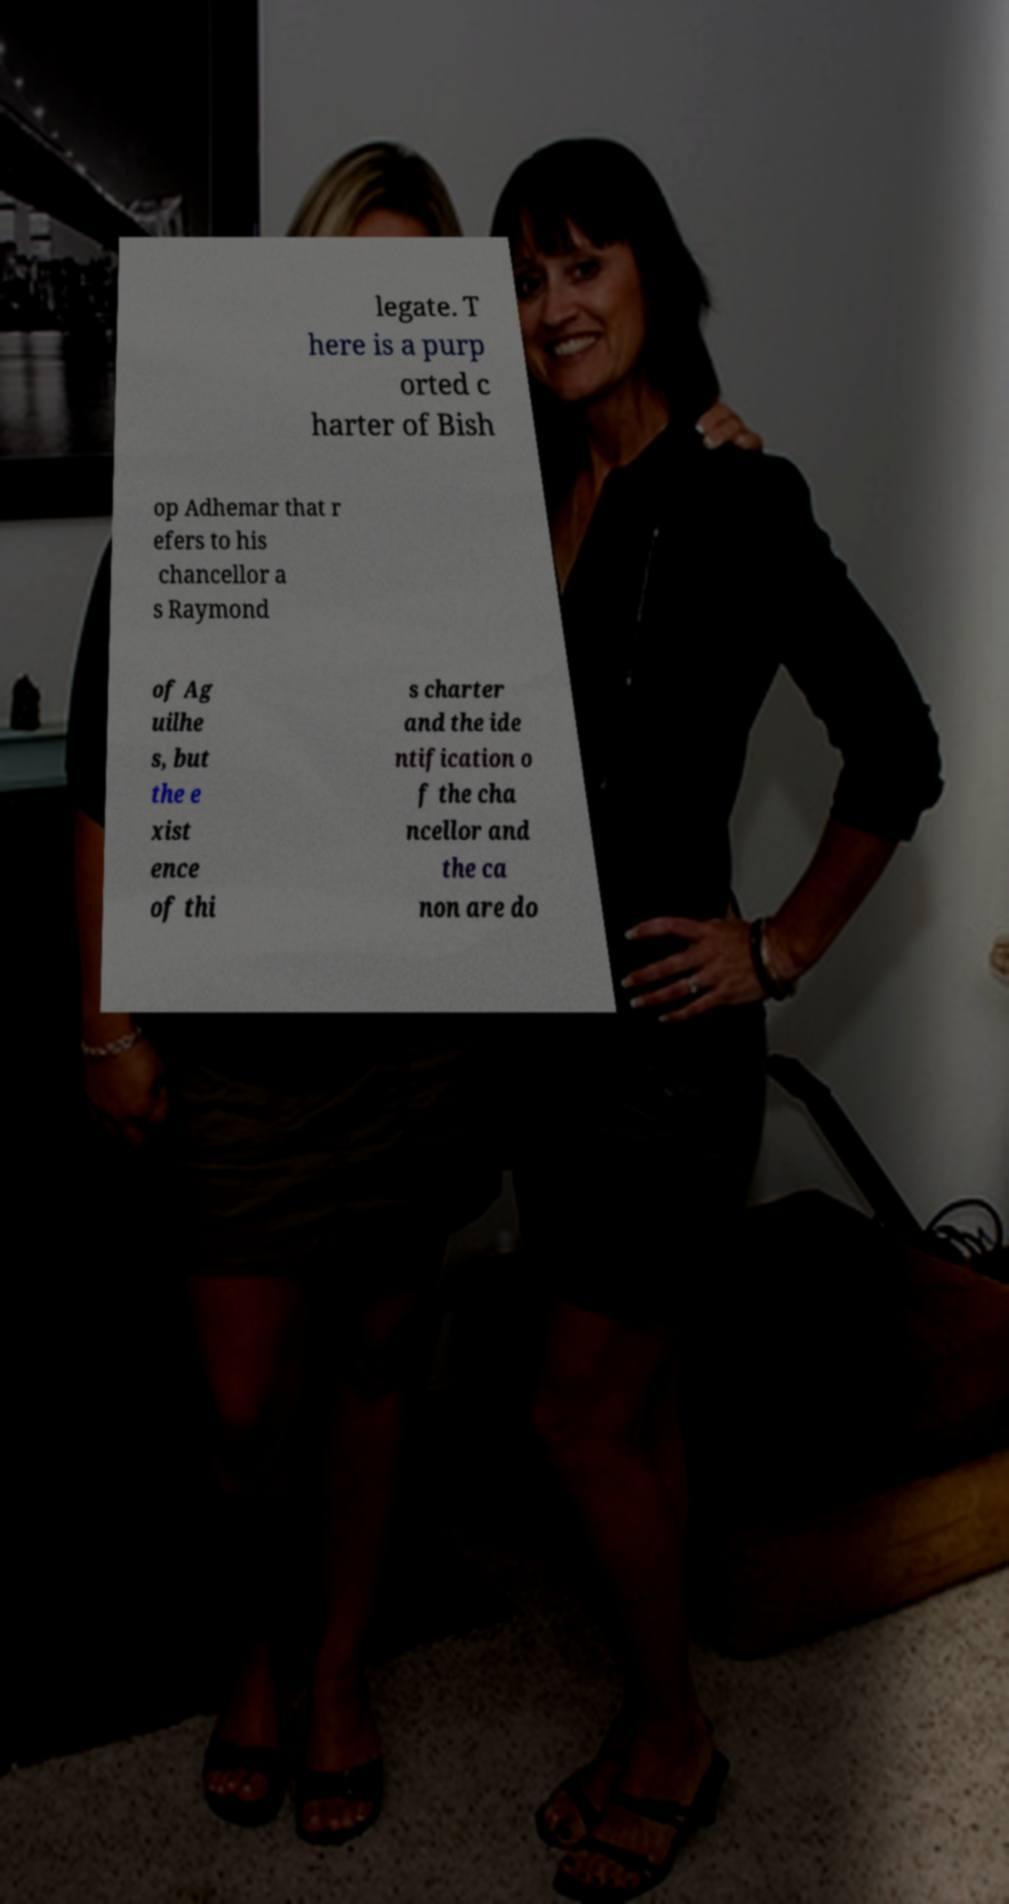Can you read and provide the text displayed in the image?This photo seems to have some interesting text. Can you extract and type it out for me? legate. T here is a purp orted c harter of Bish op Adhemar that r efers to his chancellor a s Raymond of Ag uilhe s, but the e xist ence of thi s charter and the ide ntification o f the cha ncellor and the ca non are do 